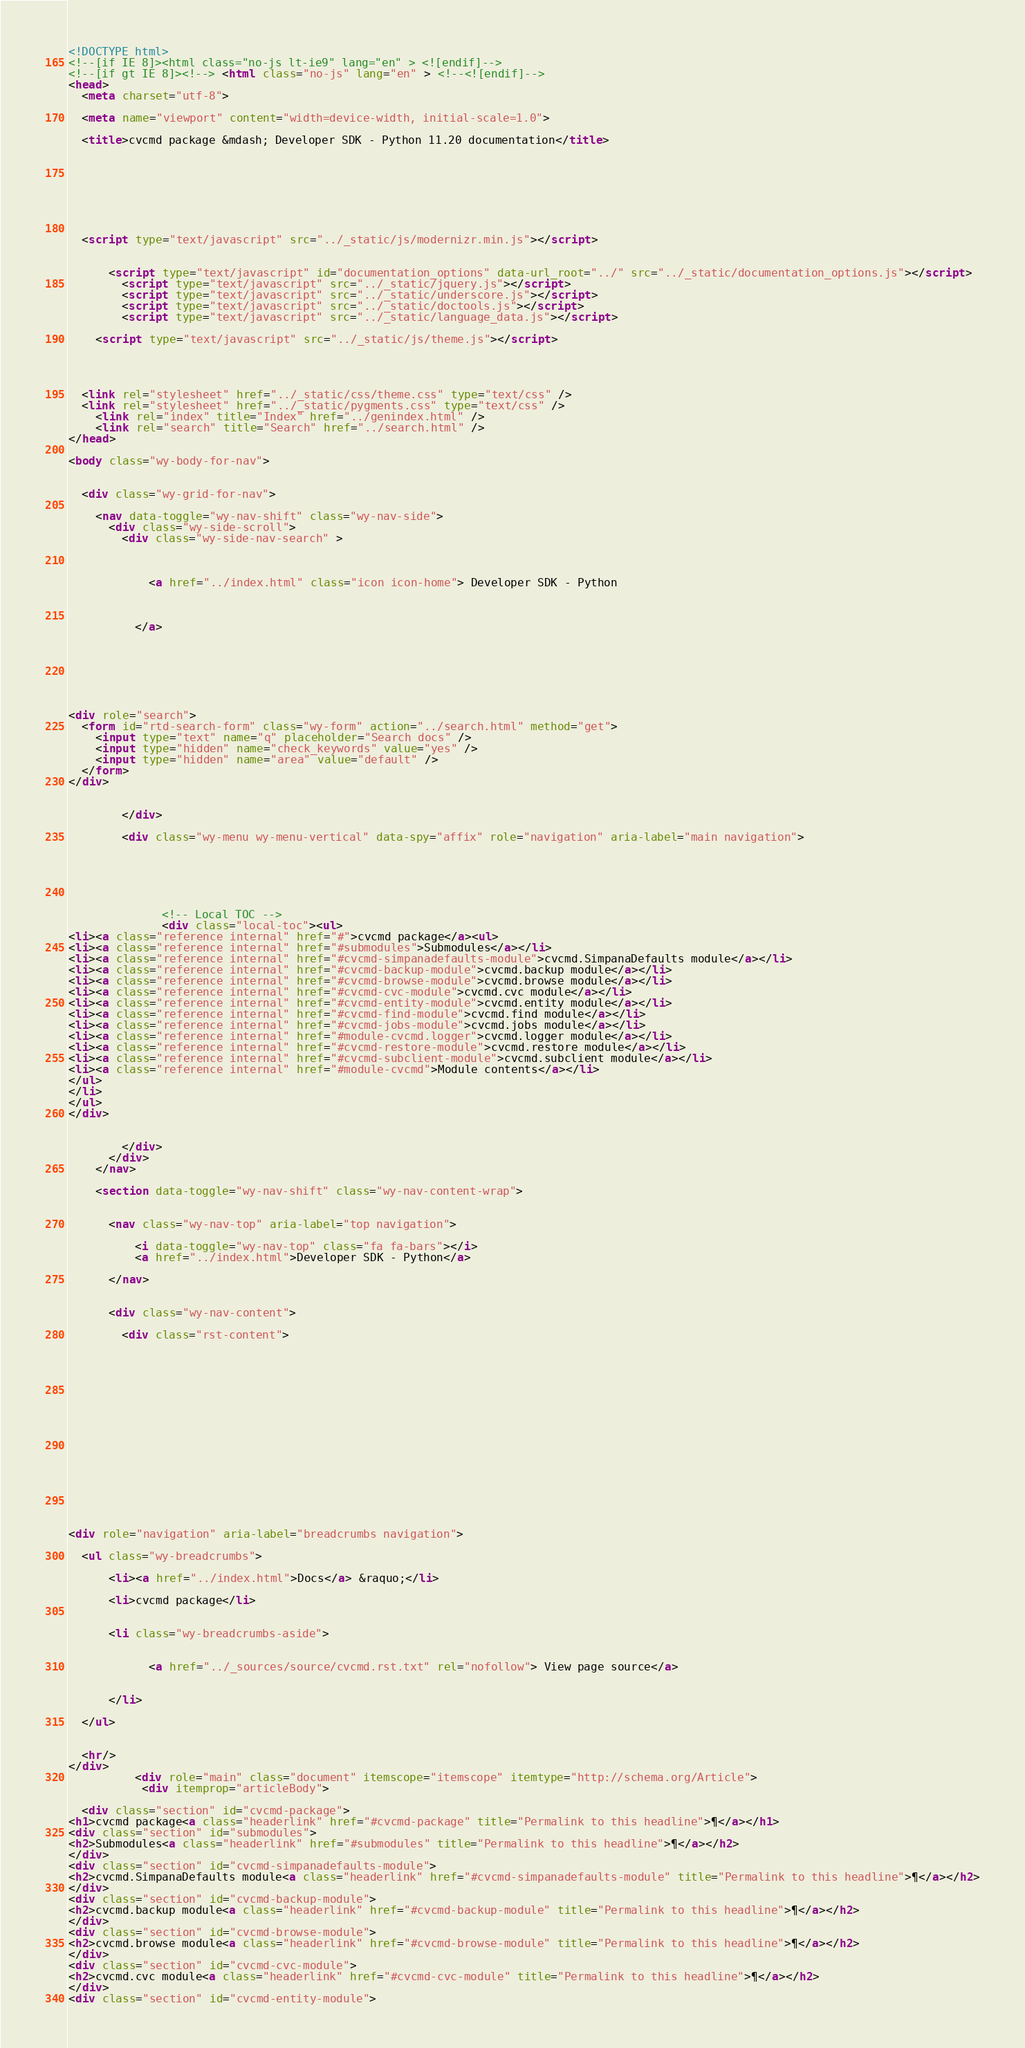Convert code to text. <code><loc_0><loc_0><loc_500><loc_500><_HTML_>

<!DOCTYPE html>
<!--[if IE 8]><html class="no-js lt-ie9" lang="en" > <![endif]-->
<!--[if gt IE 8]><!--> <html class="no-js" lang="en" > <!--<![endif]-->
<head>
  <meta charset="utf-8">
  
  <meta name="viewport" content="width=device-width, initial-scale=1.0">
  
  <title>cvcmd package &mdash; Developer SDK - Python 11.20 documentation</title>
  

  
  
  
  

  
  <script type="text/javascript" src="../_static/js/modernizr.min.js"></script>
  
    
      <script type="text/javascript" id="documentation_options" data-url_root="../" src="../_static/documentation_options.js"></script>
        <script type="text/javascript" src="../_static/jquery.js"></script>
        <script type="text/javascript" src="../_static/underscore.js"></script>
        <script type="text/javascript" src="../_static/doctools.js"></script>
        <script type="text/javascript" src="../_static/language_data.js"></script>
    
    <script type="text/javascript" src="../_static/js/theme.js"></script>

    

  
  <link rel="stylesheet" href="../_static/css/theme.css" type="text/css" />
  <link rel="stylesheet" href="../_static/pygments.css" type="text/css" />
    <link rel="index" title="Index" href="../genindex.html" />
    <link rel="search" title="Search" href="../search.html" /> 
</head>

<body class="wy-body-for-nav">

   
  <div class="wy-grid-for-nav">
    
    <nav data-toggle="wy-nav-shift" class="wy-nav-side">
      <div class="wy-side-scroll">
        <div class="wy-side-nav-search" >
          

          
            <a href="../index.html" class="icon icon-home"> Developer SDK - Python
          

          
          </a>

          
            
            
          

          
<div role="search">
  <form id="rtd-search-form" class="wy-form" action="../search.html" method="get">
    <input type="text" name="q" placeholder="Search docs" />
    <input type="hidden" name="check_keywords" value="yes" />
    <input type="hidden" name="area" value="default" />
  </form>
</div>

          
        </div>

        <div class="wy-menu wy-menu-vertical" data-spy="affix" role="navigation" aria-label="main navigation">
          
            
            
              
            
            
              <!-- Local TOC -->
              <div class="local-toc"><ul>
<li><a class="reference internal" href="#">cvcmd package</a><ul>
<li><a class="reference internal" href="#submodules">Submodules</a></li>
<li><a class="reference internal" href="#cvcmd-simpanadefaults-module">cvcmd.SimpanaDefaults module</a></li>
<li><a class="reference internal" href="#cvcmd-backup-module">cvcmd.backup module</a></li>
<li><a class="reference internal" href="#cvcmd-browse-module">cvcmd.browse module</a></li>
<li><a class="reference internal" href="#cvcmd-cvc-module">cvcmd.cvc module</a></li>
<li><a class="reference internal" href="#cvcmd-entity-module">cvcmd.entity module</a></li>
<li><a class="reference internal" href="#cvcmd-find-module">cvcmd.find module</a></li>
<li><a class="reference internal" href="#cvcmd-jobs-module">cvcmd.jobs module</a></li>
<li><a class="reference internal" href="#module-cvcmd.logger">cvcmd.logger module</a></li>
<li><a class="reference internal" href="#cvcmd-restore-module">cvcmd.restore module</a></li>
<li><a class="reference internal" href="#cvcmd-subclient-module">cvcmd.subclient module</a></li>
<li><a class="reference internal" href="#module-cvcmd">Module contents</a></li>
</ul>
</li>
</ul>
</div>
            
          
        </div>
      </div>
    </nav>

    <section data-toggle="wy-nav-shift" class="wy-nav-content-wrap">

      
      <nav class="wy-nav-top" aria-label="top navigation">
        
          <i data-toggle="wy-nav-top" class="fa fa-bars"></i>
          <a href="../index.html">Developer SDK - Python</a>
        
      </nav>


      <div class="wy-nav-content">
        
        <div class="rst-content">
        
          















<div role="navigation" aria-label="breadcrumbs navigation">

  <ul class="wy-breadcrumbs">
    
      <li><a href="../index.html">Docs</a> &raquo;</li>
        
      <li>cvcmd package</li>
    
    
      <li class="wy-breadcrumbs-aside">
        
            
            <a href="../_sources/source/cvcmd.rst.txt" rel="nofollow"> View page source</a>
          
        
      </li>
    
  </ul>

  
  <hr/>
</div>
          <div role="main" class="document" itemscope="itemscope" itemtype="http://schema.org/Article">
           <div itemprop="articleBody">
            
  <div class="section" id="cvcmd-package">
<h1>cvcmd package<a class="headerlink" href="#cvcmd-package" title="Permalink to this headline">¶</a></h1>
<div class="section" id="submodules">
<h2>Submodules<a class="headerlink" href="#submodules" title="Permalink to this headline">¶</a></h2>
</div>
<div class="section" id="cvcmd-simpanadefaults-module">
<h2>cvcmd.SimpanaDefaults module<a class="headerlink" href="#cvcmd-simpanadefaults-module" title="Permalink to this headline">¶</a></h2>
</div>
<div class="section" id="cvcmd-backup-module">
<h2>cvcmd.backup module<a class="headerlink" href="#cvcmd-backup-module" title="Permalink to this headline">¶</a></h2>
</div>
<div class="section" id="cvcmd-browse-module">
<h2>cvcmd.browse module<a class="headerlink" href="#cvcmd-browse-module" title="Permalink to this headline">¶</a></h2>
</div>
<div class="section" id="cvcmd-cvc-module">
<h2>cvcmd.cvc module<a class="headerlink" href="#cvcmd-cvc-module" title="Permalink to this headline">¶</a></h2>
</div>
<div class="section" id="cvcmd-entity-module"></code> 